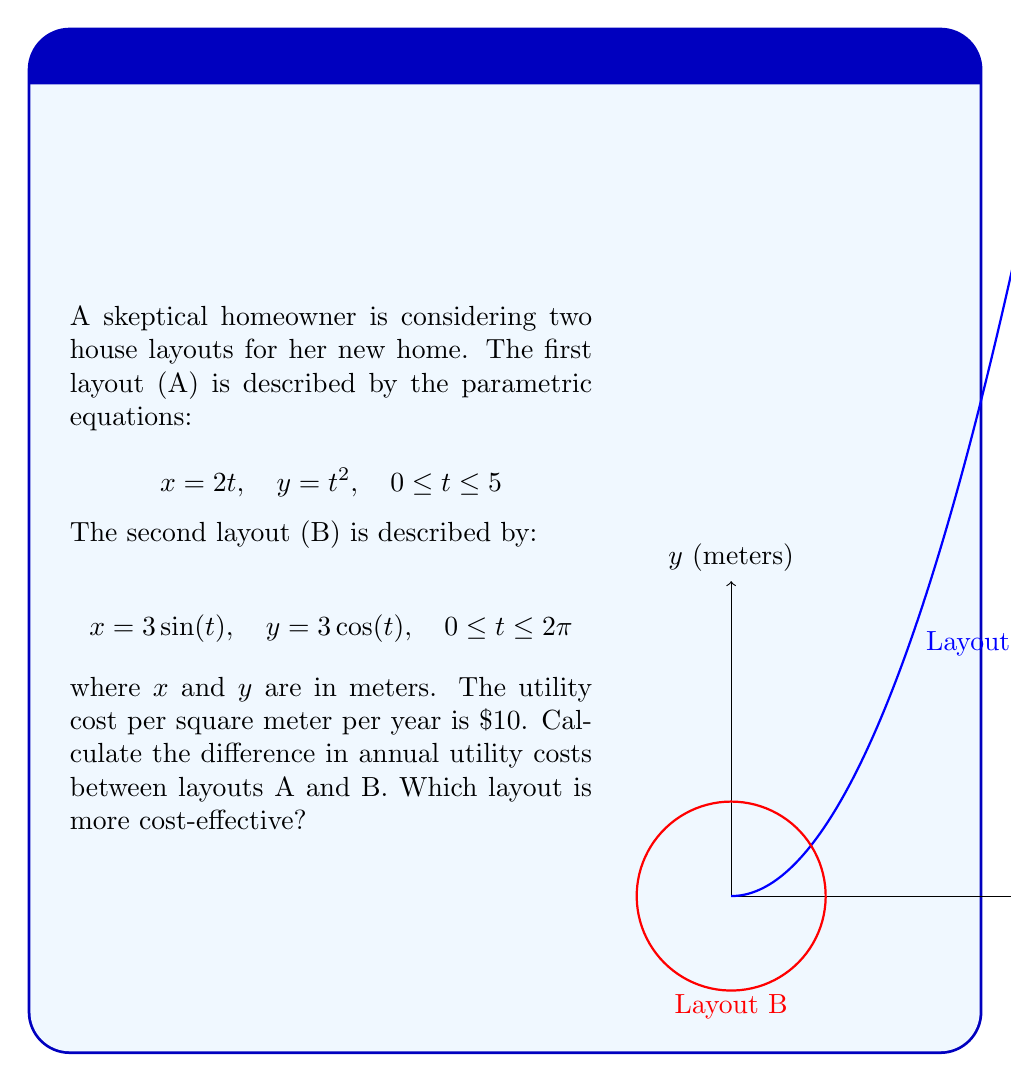Can you answer this question? To solve this problem, we need to calculate the areas of both layouts and compare their utility costs.

1. Area of Layout A:
   The area can be calculated using the formula for parametric equations:
   $$ A = \int_{0}^{5} y \frac{dx}{dt} dt = \int_{0}^{5} t^2 \cdot 2 dt = 2\int_{0}^{5} t^2 dt = 2 \cdot \frac{t^3}{3} \bigg|_{0}^{5} = \frac{250}{3} \approx 83.33 \text{ m}^2 $$

2. Area of Layout B:
   This is a circle with radius 3, so the area is:
   $$ A = \pi r^2 = \pi \cdot 3^2 = 9\pi \approx 28.27 \text{ m}^2 $$

3. Annual utility costs:
   Layout A: $83.33 \cdot \$10 = \$833.30$
   Layout B: $28.27 \cdot \$10 = \$282.70$

4. Difference in annual utility costs:
   $\$833.30 - \$282.70 = \$550.60$

Layout B is more cost-effective as it has lower annual utility costs.
Answer: $550.60; Layout B 